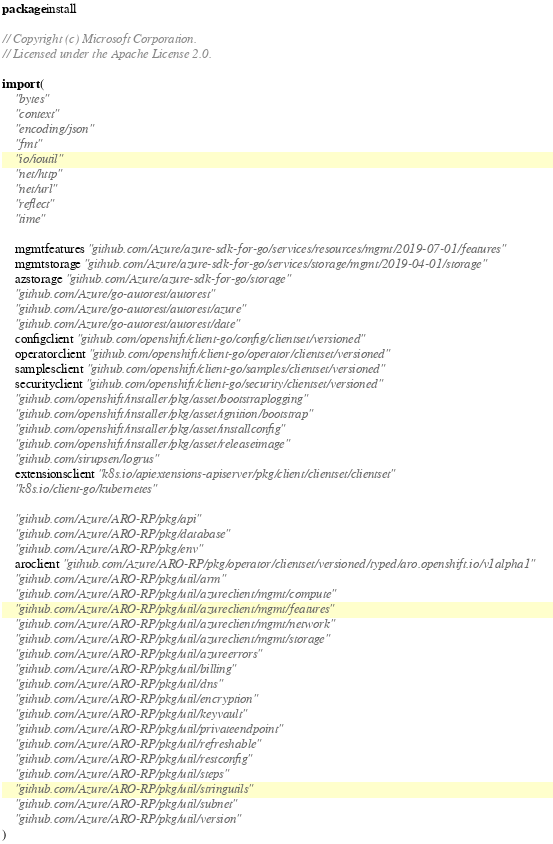<code> <loc_0><loc_0><loc_500><loc_500><_Go_>package install

// Copyright (c) Microsoft Corporation.
// Licensed under the Apache License 2.0.

import (
	"bytes"
	"context"
	"encoding/json"
	"fmt"
	"io/ioutil"
	"net/http"
	"net/url"
	"reflect"
	"time"

	mgmtfeatures "github.com/Azure/azure-sdk-for-go/services/resources/mgmt/2019-07-01/features"
	mgmtstorage "github.com/Azure/azure-sdk-for-go/services/storage/mgmt/2019-04-01/storage"
	azstorage "github.com/Azure/azure-sdk-for-go/storage"
	"github.com/Azure/go-autorest/autorest"
	"github.com/Azure/go-autorest/autorest/azure"
	"github.com/Azure/go-autorest/autorest/date"
	configclient "github.com/openshift/client-go/config/clientset/versioned"
	operatorclient "github.com/openshift/client-go/operator/clientset/versioned"
	samplesclient "github.com/openshift/client-go/samples/clientset/versioned"
	securityclient "github.com/openshift/client-go/security/clientset/versioned"
	"github.com/openshift/installer/pkg/asset/bootstraplogging"
	"github.com/openshift/installer/pkg/asset/ignition/bootstrap"
	"github.com/openshift/installer/pkg/asset/installconfig"
	"github.com/openshift/installer/pkg/asset/releaseimage"
	"github.com/sirupsen/logrus"
	extensionsclient "k8s.io/apiextensions-apiserver/pkg/client/clientset/clientset"
	"k8s.io/client-go/kubernetes"

	"github.com/Azure/ARO-RP/pkg/api"
	"github.com/Azure/ARO-RP/pkg/database"
	"github.com/Azure/ARO-RP/pkg/env"
	aroclient "github.com/Azure/ARO-RP/pkg/operator/clientset/versioned/typed/aro.openshift.io/v1alpha1"
	"github.com/Azure/ARO-RP/pkg/util/arm"
	"github.com/Azure/ARO-RP/pkg/util/azureclient/mgmt/compute"
	"github.com/Azure/ARO-RP/pkg/util/azureclient/mgmt/features"
	"github.com/Azure/ARO-RP/pkg/util/azureclient/mgmt/network"
	"github.com/Azure/ARO-RP/pkg/util/azureclient/mgmt/storage"
	"github.com/Azure/ARO-RP/pkg/util/azureerrors"
	"github.com/Azure/ARO-RP/pkg/util/billing"
	"github.com/Azure/ARO-RP/pkg/util/dns"
	"github.com/Azure/ARO-RP/pkg/util/encryption"
	"github.com/Azure/ARO-RP/pkg/util/keyvault"
	"github.com/Azure/ARO-RP/pkg/util/privateendpoint"
	"github.com/Azure/ARO-RP/pkg/util/refreshable"
	"github.com/Azure/ARO-RP/pkg/util/restconfig"
	"github.com/Azure/ARO-RP/pkg/util/steps"
	"github.com/Azure/ARO-RP/pkg/util/stringutils"
	"github.com/Azure/ARO-RP/pkg/util/subnet"
	"github.com/Azure/ARO-RP/pkg/util/version"
)
</code> 